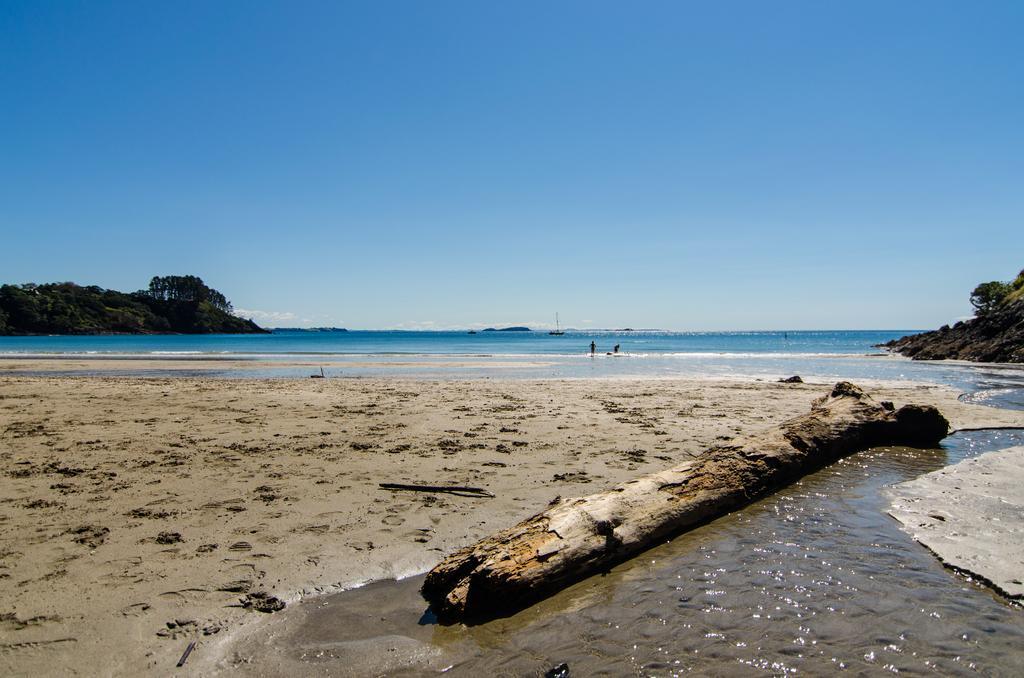In one or two sentences, can you explain what this image depicts? In this picture we can see a wooden log in water. We can see water which is blue in color at the back. There are two people standing in water. We can see some greenery on the left and right side. Sky is blue in color. 